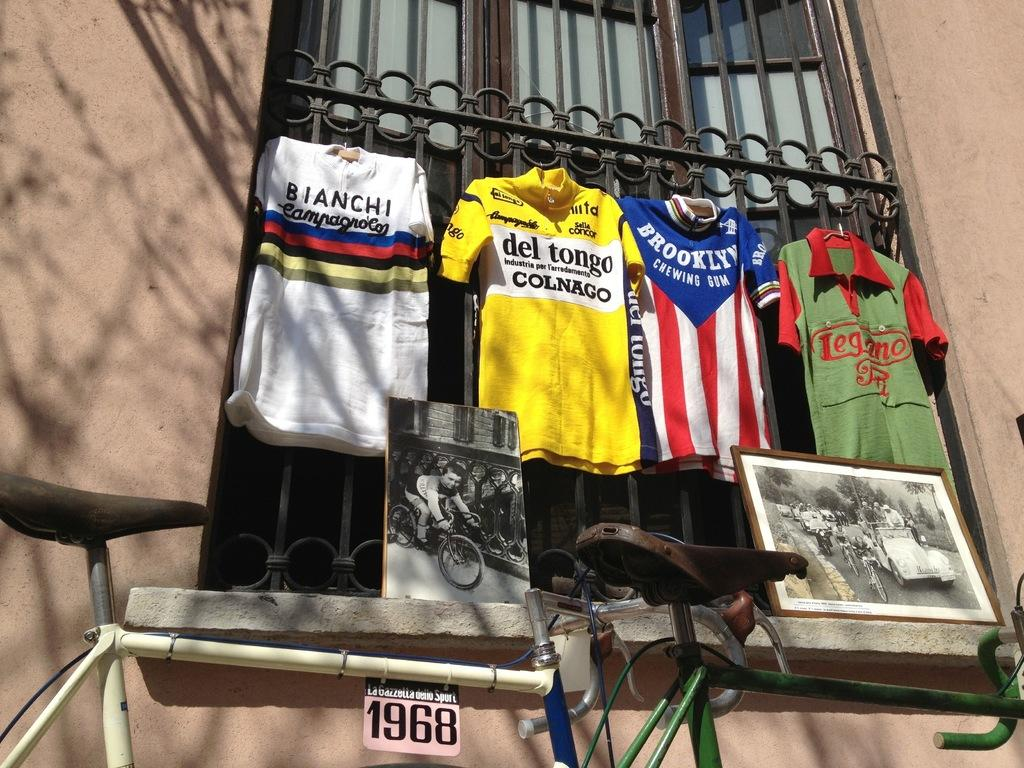<image>
Present a compact description of the photo's key features. Four jerseys hanging out a window and one is bright yellow with Del tongo Colnago displayed on the front. 